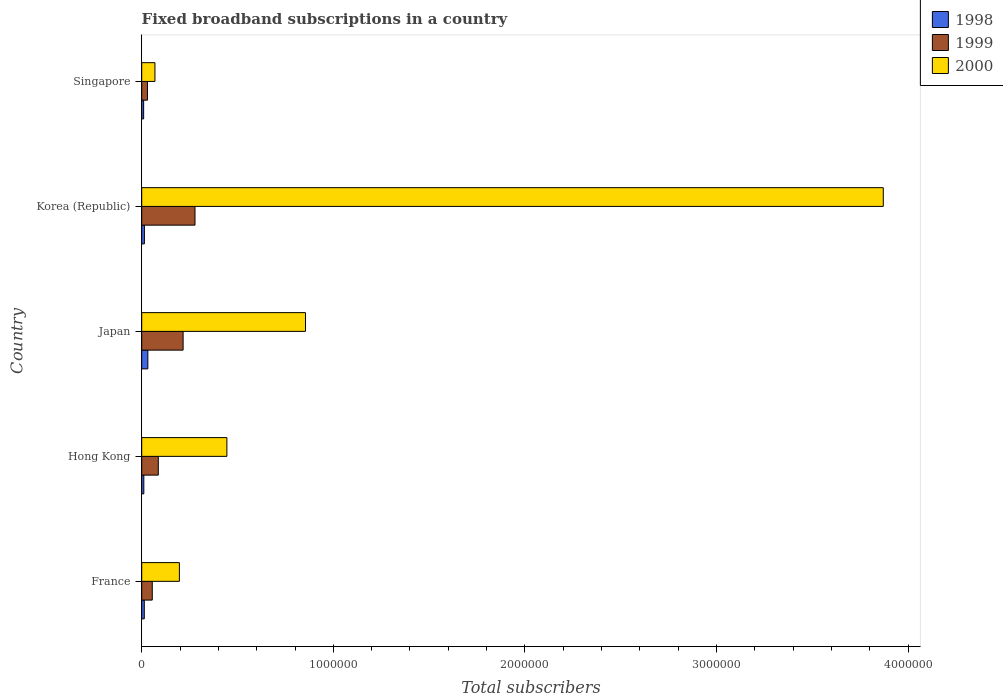How many different coloured bars are there?
Offer a terse response. 3. How many groups of bars are there?
Offer a terse response. 5. Are the number of bars per tick equal to the number of legend labels?
Provide a short and direct response. Yes. Are the number of bars on each tick of the Y-axis equal?
Ensure brevity in your answer.  Yes. How many bars are there on the 4th tick from the top?
Make the answer very short. 3. How many bars are there on the 1st tick from the bottom?
Make the answer very short. 3. In how many cases, is the number of bars for a given country not equal to the number of legend labels?
Your answer should be very brief. 0. What is the number of broadband subscriptions in 2000 in Japan?
Your answer should be compact. 8.55e+05. Across all countries, what is the maximum number of broadband subscriptions in 2000?
Ensure brevity in your answer.  3.87e+06. In which country was the number of broadband subscriptions in 2000 maximum?
Offer a terse response. Korea (Republic). In which country was the number of broadband subscriptions in 1999 minimum?
Keep it short and to the point. Singapore. What is the total number of broadband subscriptions in 2000 in the graph?
Your response must be concise. 5.43e+06. What is the difference between the number of broadband subscriptions in 1999 in Korea (Republic) and that in Singapore?
Offer a terse response. 2.48e+05. What is the difference between the number of broadband subscriptions in 1998 in Hong Kong and the number of broadband subscriptions in 1999 in France?
Your answer should be compact. -4.40e+04. What is the average number of broadband subscriptions in 1998 per country?
Your answer should be compact. 1.61e+04. What is the difference between the number of broadband subscriptions in 2000 and number of broadband subscriptions in 1998 in France?
Your response must be concise. 1.83e+05. In how many countries, is the number of broadband subscriptions in 1998 greater than 2600000 ?
Offer a terse response. 0. What is the ratio of the number of broadband subscriptions in 1998 in Japan to that in Korea (Republic)?
Give a very brief answer. 2.29. Is the number of broadband subscriptions in 2000 in France less than that in Japan?
Provide a succinct answer. Yes. What is the difference between the highest and the second highest number of broadband subscriptions in 2000?
Give a very brief answer. 3.02e+06. What is the difference between the highest and the lowest number of broadband subscriptions in 1998?
Ensure brevity in your answer.  2.20e+04. In how many countries, is the number of broadband subscriptions in 2000 greater than the average number of broadband subscriptions in 2000 taken over all countries?
Your answer should be very brief. 1. Is the sum of the number of broadband subscriptions in 1998 in France and Korea (Republic) greater than the maximum number of broadband subscriptions in 2000 across all countries?
Provide a succinct answer. No. What does the 1st bar from the top in Hong Kong represents?
Ensure brevity in your answer.  2000. Is it the case that in every country, the sum of the number of broadband subscriptions in 1999 and number of broadband subscriptions in 2000 is greater than the number of broadband subscriptions in 1998?
Make the answer very short. Yes. Are all the bars in the graph horizontal?
Your answer should be very brief. Yes. How many countries are there in the graph?
Your answer should be compact. 5. Does the graph contain any zero values?
Keep it short and to the point. No. Does the graph contain grids?
Your answer should be very brief. No. How are the legend labels stacked?
Offer a terse response. Vertical. What is the title of the graph?
Provide a short and direct response. Fixed broadband subscriptions in a country. What is the label or title of the X-axis?
Ensure brevity in your answer.  Total subscribers. What is the Total subscribers of 1998 in France?
Your answer should be very brief. 1.35e+04. What is the Total subscribers of 1999 in France?
Your response must be concise. 5.50e+04. What is the Total subscribers of 2000 in France?
Your answer should be compact. 1.97e+05. What is the Total subscribers in 1998 in Hong Kong?
Your answer should be very brief. 1.10e+04. What is the Total subscribers in 1999 in Hong Kong?
Provide a succinct answer. 8.65e+04. What is the Total subscribers in 2000 in Hong Kong?
Provide a short and direct response. 4.44e+05. What is the Total subscribers in 1998 in Japan?
Provide a short and direct response. 3.20e+04. What is the Total subscribers of 1999 in Japan?
Give a very brief answer. 2.16e+05. What is the Total subscribers in 2000 in Japan?
Make the answer very short. 8.55e+05. What is the Total subscribers in 1998 in Korea (Republic)?
Give a very brief answer. 1.40e+04. What is the Total subscribers in 1999 in Korea (Republic)?
Your answer should be very brief. 2.78e+05. What is the Total subscribers in 2000 in Korea (Republic)?
Offer a terse response. 3.87e+06. What is the Total subscribers in 2000 in Singapore?
Your answer should be very brief. 6.90e+04. Across all countries, what is the maximum Total subscribers in 1998?
Keep it short and to the point. 3.20e+04. Across all countries, what is the maximum Total subscribers in 1999?
Offer a very short reply. 2.78e+05. Across all countries, what is the maximum Total subscribers of 2000?
Offer a terse response. 3.87e+06. Across all countries, what is the minimum Total subscribers in 1998?
Your answer should be very brief. 10000. Across all countries, what is the minimum Total subscribers in 1999?
Your answer should be compact. 3.00e+04. Across all countries, what is the minimum Total subscribers of 2000?
Keep it short and to the point. 6.90e+04. What is the total Total subscribers in 1998 in the graph?
Give a very brief answer. 8.05e+04. What is the total Total subscribers in 1999 in the graph?
Your response must be concise. 6.65e+05. What is the total Total subscribers of 2000 in the graph?
Ensure brevity in your answer.  5.43e+06. What is the difference between the Total subscribers of 1998 in France and that in Hong Kong?
Your answer should be very brief. 2464. What is the difference between the Total subscribers in 1999 in France and that in Hong Kong?
Offer a very short reply. -3.15e+04. What is the difference between the Total subscribers of 2000 in France and that in Hong Kong?
Provide a succinct answer. -2.48e+05. What is the difference between the Total subscribers of 1998 in France and that in Japan?
Give a very brief answer. -1.85e+04. What is the difference between the Total subscribers in 1999 in France and that in Japan?
Provide a short and direct response. -1.61e+05. What is the difference between the Total subscribers of 2000 in France and that in Japan?
Your answer should be very brief. -6.58e+05. What is the difference between the Total subscribers in 1998 in France and that in Korea (Republic)?
Offer a very short reply. -536. What is the difference between the Total subscribers of 1999 in France and that in Korea (Republic)?
Make the answer very short. -2.23e+05. What is the difference between the Total subscribers in 2000 in France and that in Korea (Republic)?
Provide a succinct answer. -3.67e+06. What is the difference between the Total subscribers of 1998 in France and that in Singapore?
Ensure brevity in your answer.  3464. What is the difference between the Total subscribers of 1999 in France and that in Singapore?
Keep it short and to the point. 2.50e+04. What is the difference between the Total subscribers in 2000 in France and that in Singapore?
Provide a short and direct response. 1.28e+05. What is the difference between the Total subscribers of 1998 in Hong Kong and that in Japan?
Offer a terse response. -2.10e+04. What is the difference between the Total subscribers of 1999 in Hong Kong and that in Japan?
Provide a short and direct response. -1.30e+05. What is the difference between the Total subscribers of 2000 in Hong Kong and that in Japan?
Provide a short and direct response. -4.10e+05. What is the difference between the Total subscribers in 1998 in Hong Kong and that in Korea (Republic)?
Provide a short and direct response. -3000. What is the difference between the Total subscribers of 1999 in Hong Kong and that in Korea (Republic)?
Your response must be concise. -1.92e+05. What is the difference between the Total subscribers in 2000 in Hong Kong and that in Korea (Republic)?
Keep it short and to the point. -3.43e+06. What is the difference between the Total subscribers of 1998 in Hong Kong and that in Singapore?
Offer a terse response. 1000. What is the difference between the Total subscribers in 1999 in Hong Kong and that in Singapore?
Provide a short and direct response. 5.65e+04. What is the difference between the Total subscribers of 2000 in Hong Kong and that in Singapore?
Provide a succinct answer. 3.75e+05. What is the difference between the Total subscribers of 1998 in Japan and that in Korea (Republic)?
Your answer should be very brief. 1.80e+04. What is the difference between the Total subscribers of 1999 in Japan and that in Korea (Republic)?
Your answer should be very brief. -6.20e+04. What is the difference between the Total subscribers in 2000 in Japan and that in Korea (Republic)?
Your answer should be compact. -3.02e+06. What is the difference between the Total subscribers in 1998 in Japan and that in Singapore?
Provide a short and direct response. 2.20e+04. What is the difference between the Total subscribers in 1999 in Japan and that in Singapore?
Keep it short and to the point. 1.86e+05. What is the difference between the Total subscribers in 2000 in Japan and that in Singapore?
Provide a succinct answer. 7.86e+05. What is the difference between the Total subscribers of 1998 in Korea (Republic) and that in Singapore?
Keep it short and to the point. 4000. What is the difference between the Total subscribers of 1999 in Korea (Republic) and that in Singapore?
Offer a terse response. 2.48e+05. What is the difference between the Total subscribers of 2000 in Korea (Republic) and that in Singapore?
Your answer should be compact. 3.80e+06. What is the difference between the Total subscribers of 1998 in France and the Total subscribers of 1999 in Hong Kong?
Provide a short and direct response. -7.30e+04. What is the difference between the Total subscribers of 1998 in France and the Total subscribers of 2000 in Hong Kong?
Your answer should be compact. -4.31e+05. What is the difference between the Total subscribers of 1999 in France and the Total subscribers of 2000 in Hong Kong?
Your answer should be very brief. -3.89e+05. What is the difference between the Total subscribers in 1998 in France and the Total subscribers in 1999 in Japan?
Offer a very short reply. -2.03e+05. What is the difference between the Total subscribers in 1998 in France and the Total subscribers in 2000 in Japan?
Your response must be concise. -8.41e+05. What is the difference between the Total subscribers in 1999 in France and the Total subscribers in 2000 in Japan?
Your response must be concise. -8.00e+05. What is the difference between the Total subscribers in 1998 in France and the Total subscribers in 1999 in Korea (Republic)?
Give a very brief answer. -2.65e+05. What is the difference between the Total subscribers of 1998 in France and the Total subscribers of 2000 in Korea (Republic)?
Your answer should be compact. -3.86e+06. What is the difference between the Total subscribers of 1999 in France and the Total subscribers of 2000 in Korea (Republic)?
Your answer should be compact. -3.82e+06. What is the difference between the Total subscribers in 1998 in France and the Total subscribers in 1999 in Singapore?
Your response must be concise. -1.65e+04. What is the difference between the Total subscribers of 1998 in France and the Total subscribers of 2000 in Singapore?
Your answer should be compact. -5.55e+04. What is the difference between the Total subscribers in 1999 in France and the Total subscribers in 2000 in Singapore?
Offer a very short reply. -1.40e+04. What is the difference between the Total subscribers of 1998 in Hong Kong and the Total subscribers of 1999 in Japan?
Your answer should be very brief. -2.05e+05. What is the difference between the Total subscribers in 1998 in Hong Kong and the Total subscribers in 2000 in Japan?
Give a very brief answer. -8.44e+05. What is the difference between the Total subscribers of 1999 in Hong Kong and the Total subscribers of 2000 in Japan?
Ensure brevity in your answer.  -7.68e+05. What is the difference between the Total subscribers of 1998 in Hong Kong and the Total subscribers of 1999 in Korea (Republic)?
Offer a very short reply. -2.67e+05. What is the difference between the Total subscribers of 1998 in Hong Kong and the Total subscribers of 2000 in Korea (Republic)?
Provide a short and direct response. -3.86e+06. What is the difference between the Total subscribers in 1999 in Hong Kong and the Total subscribers in 2000 in Korea (Republic)?
Offer a terse response. -3.78e+06. What is the difference between the Total subscribers of 1998 in Hong Kong and the Total subscribers of 1999 in Singapore?
Your answer should be very brief. -1.90e+04. What is the difference between the Total subscribers of 1998 in Hong Kong and the Total subscribers of 2000 in Singapore?
Ensure brevity in your answer.  -5.80e+04. What is the difference between the Total subscribers of 1999 in Hong Kong and the Total subscribers of 2000 in Singapore?
Keep it short and to the point. 1.75e+04. What is the difference between the Total subscribers of 1998 in Japan and the Total subscribers of 1999 in Korea (Republic)?
Your answer should be compact. -2.46e+05. What is the difference between the Total subscribers in 1998 in Japan and the Total subscribers in 2000 in Korea (Republic)?
Your answer should be very brief. -3.84e+06. What is the difference between the Total subscribers of 1999 in Japan and the Total subscribers of 2000 in Korea (Republic)?
Give a very brief answer. -3.65e+06. What is the difference between the Total subscribers of 1998 in Japan and the Total subscribers of 1999 in Singapore?
Give a very brief answer. 2000. What is the difference between the Total subscribers of 1998 in Japan and the Total subscribers of 2000 in Singapore?
Make the answer very short. -3.70e+04. What is the difference between the Total subscribers in 1999 in Japan and the Total subscribers in 2000 in Singapore?
Offer a terse response. 1.47e+05. What is the difference between the Total subscribers of 1998 in Korea (Republic) and the Total subscribers of 1999 in Singapore?
Your response must be concise. -1.60e+04. What is the difference between the Total subscribers of 1998 in Korea (Republic) and the Total subscribers of 2000 in Singapore?
Give a very brief answer. -5.50e+04. What is the difference between the Total subscribers of 1999 in Korea (Republic) and the Total subscribers of 2000 in Singapore?
Offer a terse response. 2.09e+05. What is the average Total subscribers in 1998 per country?
Give a very brief answer. 1.61e+04. What is the average Total subscribers of 1999 per country?
Provide a short and direct response. 1.33e+05. What is the average Total subscribers in 2000 per country?
Your answer should be very brief. 1.09e+06. What is the difference between the Total subscribers in 1998 and Total subscribers in 1999 in France?
Keep it short and to the point. -4.15e+04. What is the difference between the Total subscribers in 1998 and Total subscribers in 2000 in France?
Your response must be concise. -1.83e+05. What is the difference between the Total subscribers in 1999 and Total subscribers in 2000 in France?
Your answer should be very brief. -1.42e+05. What is the difference between the Total subscribers of 1998 and Total subscribers of 1999 in Hong Kong?
Your answer should be very brief. -7.55e+04. What is the difference between the Total subscribers of 1998 and Total subscribers of 2000 in Hong Kong?
Your response must be concise. -4.33e+05. What is the difference between the Total subscribers in 1999 and Total subscribers in 2000 in Hong Kong?
Keep it short and to the point. -3.58e+05. What is the difference between the Total subscribers in 1998 and Total subscribers in 1999 in Japan?
Provide a succinct answer. -1.84e+05. What is the difference between the Total subscribers in 1998 and Total subscribers in 2000 in Japan?
Provide a short and direct response. -8.23e+05. What is the difference between the Total subscribers in 1999 and Total subscribers in 2000 in Japan?
Your response must be concise. -6.39e+05. What is the difference between the Total subscribers in 1998 and Total subscribers in 1999 in Korea (Republic)?
Offer a very short reply. -2.64e+05. What is the difference between the Total subscribers in 1998 and Total subscribers in 2000 in Korea (Republic)?
Offer a very short reply. -3.86e+06. What is the difference between the Total subscribers of 1999 and Total subscribers of 2000 in Korea (Republic)?
Give a very brief answer. -3.59e+06. What is the difference between the Total subscribers in 1998 and Total subscribers in 1999 in Singapore?
Offer a terse response. -2.00e+04. What is the difference between the Total subscribers of 1998 and Total subscribers of 2000 in Singapore?
Ensure brevity in your answer.  -5.90e+04. What is the difference between the Total subscribers in 1999 and Total subscribers in 2000 in Singapore?
Make the answer very short. -3.90e+04. What is the ratio of the Total subscribers in 1998 in France to that in Hong Kong?
Your answer should be very brief. 1.22. What is the ratio of the Total subscribers of 1999 in France to that in Hong Kong?
Provide a short and direct response. 0.64. What is the ratio of the Total subscribers of 2000 in France to that in Hong Kong?
Provide a short and direct response. 0.44. What is the ratio of the Total subscribers of 1998 in France to that in Japan?
Ensure brevity in your answer.  0.42. What is the ratio of the Total subscribers of 1999 in France to that in Japan?
Keep it short and to the point. 0.25. What is the ratio of the Total subscribers of 2000 in France to that in Japan?
Provide a succinct answer. 0.23. What is the ratio of the Total subscribers of 1998 in France to that in Korea (Republic)?
Provide a short and direct response. 0.96. What is the ratio of the Total subscribers in 1999 in France to that in Korea (Republic)?
Keep it short and to the point. 0.2. What is the ratio of the Total subscribers of 2000 in France to that in Korea (Republic)?
Your answer should be very brief. 0.05. What is the ratio of the Total subscribers of 1998 in France to that in Singapore?
Provide a succinct answer. 1.35. What is the ratio of the Total subscribers in 1999 in France to that in Singapore?
Ensure brevity in your answer.  1.83. What is the ratio of the Total subscribers of 2000 in France to that in Singapore?
Your answer should be compact. 2.85. What is the ratio of the Total subscribers in 1998 in Hong Kong to that in Japan?
Keep it short and to the point. 0.34. What is the ratio of the Total subscribers of 1999 in Hong Kong to that in Japan?
Make the answer very short. 0.4. What is the ratio of the Total subscribers in 2000 in Hong Kong to that in Japan?
Keep it short and to the point. 0.52. What is the ratio of the Total subscribers of 1998 in Hong Kong to that in Korea (Republic)?
Provide a short and direct response. 0.79. What is the ratio of the Total subscribers in 1999 in Hong Kong to that in Korea (Republic)?
Your response must be concise. 0.31. What is the ratio of the Total subscribers of 2000 in Hong Kong to that in Korea (Republic)?
Keep it short and to the point. 0.11. What is the ratio of the Total subscribers in 1999 in Hong Kong to that in Singapore?
Provide a short and direct response. 2.88. What is the ratio of the Total subscribers in 2000 in Hong Kong to that in Singapore?
Your response must be concise. 6.44. What is the ratio of the Total subscribers of 1998 in Japan to that in Korea (Republic)?
Keep it short and to the point. 2.29. What is the ratio of the Total subscribers in 1999 in Japan to that in Korea (Republic)?
Your response must be concise. 0.78. What is the ratio of the Total subscribers in 2000 in Japan to that in Korea (Republic)?
Give a very brief answer. 0.22. What is the ratio of the Total subscribers in 1998 in Japan to that in Singapore?
Offer a very short reply. 3.2. What is the ratio of the Total subscribers of 2000 in Japan to that in Singapore?
Offer a very short reply. 12.39. What is the ratio of the Total subscribers of 1999 in Korea (Republic) to that in Singapore?
Make the answer very short. 9.27. What is the ratio of the Total subscribers of 2000 in Korea (Republic) to that in Singapore?
Provide a succinct answer. 56.09. What is the difference between the highest and the second highest Total subscribers of 1998?
Offer a very short reply. 1.80e+04. What is the difference between the highest and the second highest Total subscribers of 1999?
Make the answer very short. 6.20e+04. What is the difference between the highest and the second highest Total subscribers of 2000?
Give a very brief answer. 3.02e+06. What is the difference between the highest and the lowest Total subscribers in 1998?
Your answer should be compact. 2.20e+04. What is the difference between the highest and the lowest Total subscribers of 1999?
Provide a succinct answer. 2.48e+05. What is the difference between the highest and the lowest Total subscribers of 2000?
Provide a short and direct response. 3.80e+06. 